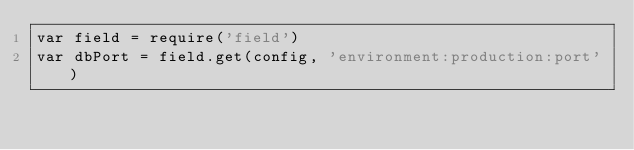<code> <loc_0><loc_0><loc_500><loc_500><_JavaScript_>var field = require('field')
var dbPort = field.get(config, 'environment:production:port')
</code> 